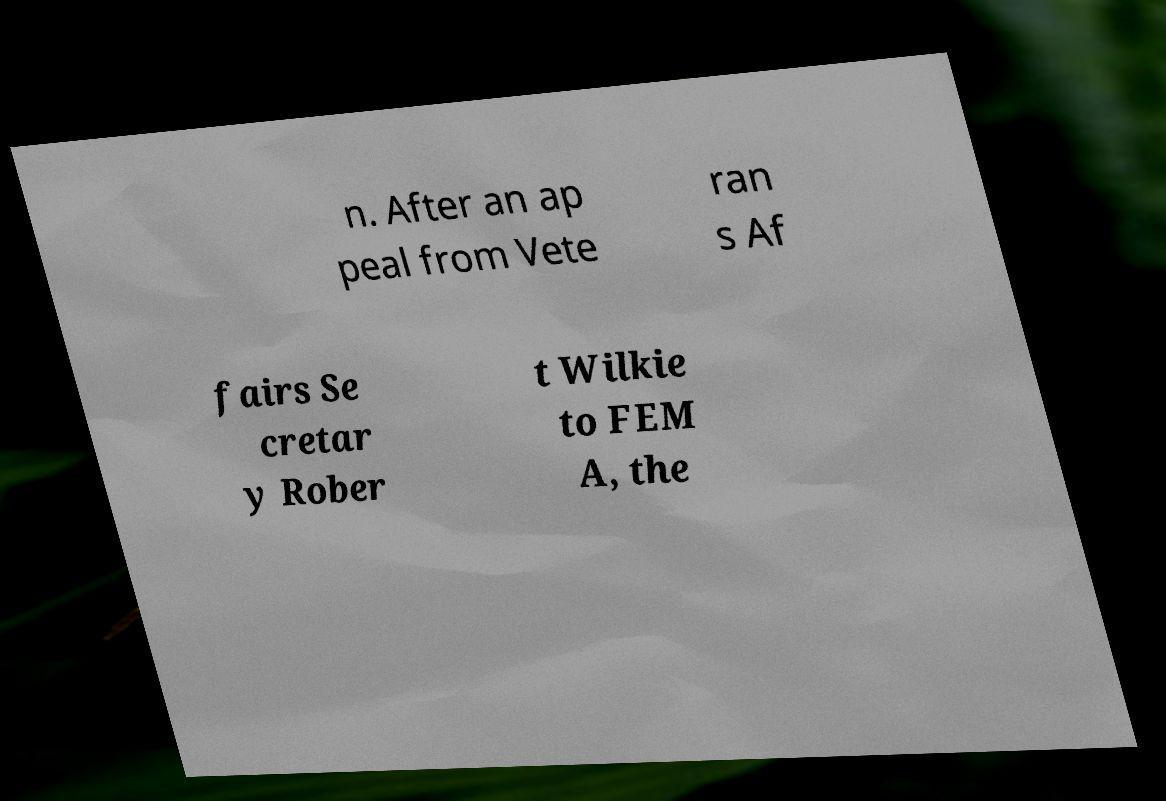I need the written content from this picture converted into text. Can you do that? n. After an ap peal from Vete ran s Af fairs Se cretar y Rober t Wilkie to FEM A, the 